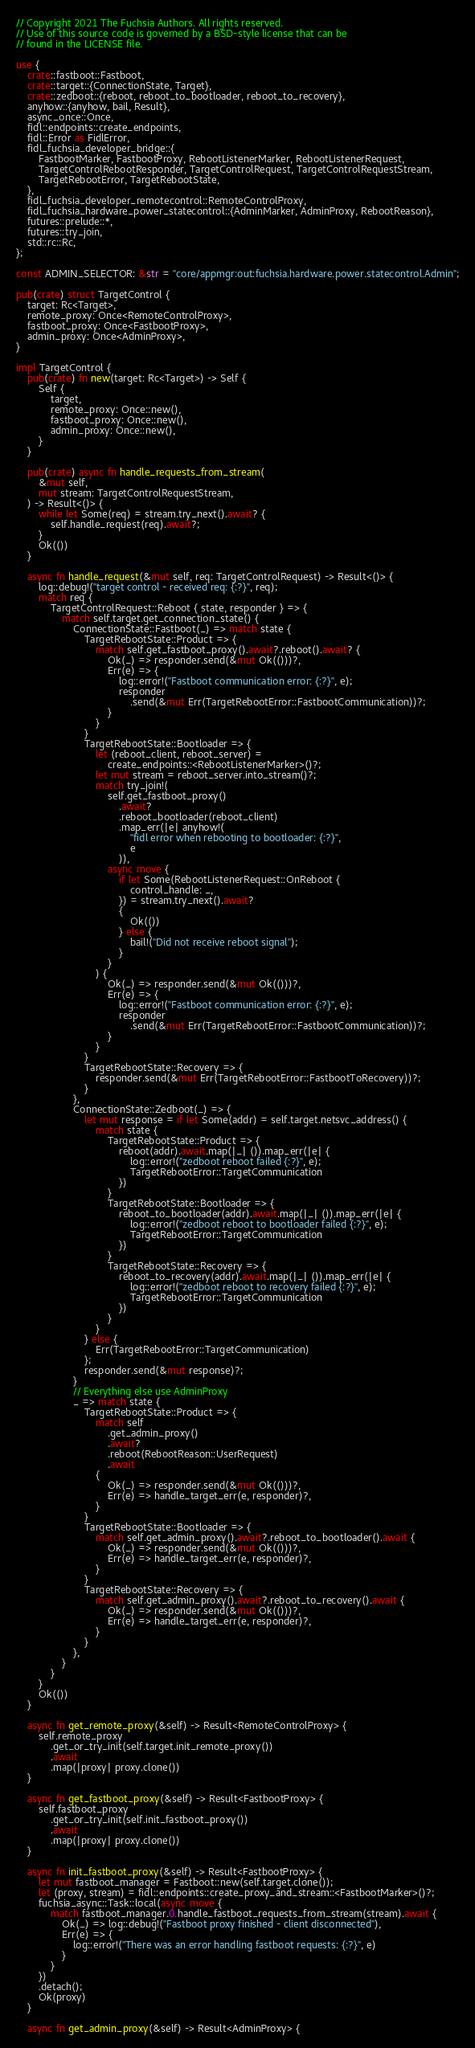Convert code to text. <code><loc_0><loc_0><loc_500><loc_500><_Rust_>// Copyright 2021 The Fuchsia Authors. All rights reserved.
// Use of this source code is governed by a BSD-style license that can be
// found in the LICENSE file.

use {
    crate::fastboot::Fastboot,
    crate::target::{ConnectionState, Target},
    crate::zedboot::{reboot, reboot_to_bootloader, reboot_to_recovery},
    anyhow::{anyhow, bail, Result},
    async_once::Once,
    fidl::endpoints::create_endpoints,
    fidl::Error as FidlError,
    fidl_fuchsia_developer_bridge::{
        FastbootMarker, FastbootProxy, RebootListenerMarker, RebootListenerRequest,
        TargetControlRebootResponder, TargetControlRequest, TargetControlRequestStream,
        TargetRebootError, TargetRebootState,
    },
    fidl_fuchsia_developer_remotecontrol::RemoteControlProxy,
    fidl_fuchsia_hardware_power_statecontrol::{AdminMarker, AdminProxy, RebootReason},
    futures::prelude::*,
    futures::try_join,
    std::rc::Rc,
};

const ADMIN_SELECTOR: &str = "core/appmgr:out:fuchsia.hardware.power.statecontrol.Admin";

pub(crate) struct TargetControl {
    target: Rc<Target>,
    remote_proxy: Once<RemoteControlProxy>,
    fastboot_proxy: Once<FastbootProxy>,
    admin_proxy: Once<AdminProxy>,
}

impl TargetControl {
    pub(crate) fn new(target: Rc<Target>) -> Self {
        Self {
            target,
            remote_proxy: Once::new(),
            fastboot_proxy: Once::new(),
            admin_proxy: Once::new(),
        }
    }

    pub(crate) async fn handle_requests_from_stream(
        &mut self,
        mut stream: TargetControlRequestStream,
    ) -> Result<()> {
        while let Some(req) = stream.try_next().await? {
            self.handle_request(req).await?;
        }
        Ok(())
    }

    async fn handle_request(&mut self, req: TargetControlRequest) -> Result<()> {
        log::debug!("target control - received req: {:?}", req);
        match req {
            TargetControlRequest::Reboot { state, responder } => {
                match self.target.get_connection_state() {
                    ConnectionState::Fastboot(_) => match state {
                        TargetRebootState::Product => {
                            match self.get_fastboot_proxy().await?.reboot().await? {
                                Ok(_) => responder.send(&mut Ok(()))?,
                                Err(e) => {
                                    log::error!("Fastboot communication error: {:?}", e);
                                    responder
                                        .send(&mut Err(TargetRebootError::FastbootCommunication))?;
                                }
                            }
                        }
                        TargetRebootState::Bootloader => {
                            let (reboot_client, reboot_server) =
                                create_endpoints::<RebootListenerMarker>()?;
                            let mut stream = reboot_server.into_stream()?;
                            match try_join!(
                                self.get_fastboot_proxy()
                                    .await?
                                    .reboot_bootloader(reboot_client)
                                    .map_err(|e| anyhow!(
                                        "fidl error when rebooting to bootloader: {:?}",
                                        e
                                    )),
                                async move {
                                    if let Some(RebootListenerRequest::OnReboot {
                                        control_handle: _,
                                    }) = stream.try_next().await?
                                    {
                                        Ok(())
                                    } else {
                                        bail!("Did not receive reboot signal");
                                    }
                                }
                            ) {
                                Ok(_) => responder.send(&mut Ok(()))?,
                                Err(e) => {
                                    log::error!("Fastboot communication error: {:?}", e);
                                    responder
                                        .send(&mut Err(TargetRebootError::FastbootCommunication))?;
                                }
                            }
                        }
                        TargetRebootState::Recovery => {
                            responder.send(&mut Err(TargetRebootError::FastbootToRecovery))?;
                        }
                    },
                    ConnectionState::Zedboot(_) => {
                        let mut response = if let Some(addr) = self.target.netsvc_address() {
                            match state {
                                TargetRebootState::Product => {
                                    reboot(addr).await.map(|_| ()).map_err(|e| {
                                        log::error!("zedboot reboot failed {:?}", e);
                                        TargetRebootError::TargetCommunication
                                    })
                                }
                                TargetRebootState::Bootloader => {
                                    reboot_to_bootloader(addr).await.map(|_| ()).map_err(|e| {
                                        log::error!("zedboot reboot to bootloader failed {:?}", e);
                                        TargetRebootError::TargetCommunication
                                    })
                                }
                                TargetRebootState::Recovery => {
                                    reboot_to_recovery(addr).await.map(|_| ()).map_err(|e| {
                                        log::error!("zedboot reboot to recovery failed {:?}", e);
                                        TargetRebootError::TargetCommunication
                                    })
                                }
                            }
                        } else {
                            Err(TargetRebootError::TargetCommunication)
                        };
                        responder.send(&mut response)?;
                    }
                    // Everything else use AdminProxy
                    _ => match state {
                        TargetRebootState::Product => {
                            match self
                                .get_admin_proxy()
                                .await?
                                .reboot(RebootReason::UserRequest)
                                .await
                            {
                                Ok(_) => responder.send(&mut Ok(()))?,
                                Err(e) => handle_target_err(e, responder)?,
                            }
                        }
                        TargetRebootState::Bootloader => {
                            match self.get_admin_proxy().await?.reboot_to_bootloader().await {
                                Ok(_) => responder.send(&mut Ok(()))?,
                                Err(e) => handle_target_err(e, responder)?,
                            }
                        }
                        TargetRebootState::Recovery => {
                            match self.get_admin_proxy().await?.reboot_to_recovery().await {
                                Ok(_) => responder.send(&mut Ok(()))?,
                                Err(e) => handle_target_err(e, responder)?,
                            }
                        }
                    },
                }
            }
        }
        Ok(())
    }

    async fn get_remote_proxy(&self) -> Result<RemoteControlProxy> {
        self.remote_proxy
            .get_or_try_init(self.target.init_remote_proxy())
            .await
            .map(|proxy| proxy.clone())
    }

    async fn get_fastboot_proxy(&self) -> Result<FastbootProxy> {
        self.fastboot_proxy
            .get_or_try_init(self.init_fastboot_proxy())
            .await
            .map(|proxy| proxy.clone())
    }

    async fn init_fastboot_proxy(&self) -> Result<FastbootProxy> {
        let mut fastboot_manager = Fastboot::new(self.target.clone());
        let (proxy, stream) = fidl::endpoints::create_proxy_and_stream::<FastbootMarker>()?;
        fuchsia_async::Task::local(async move {
            match fastboot_manager.0.handle_fastboot_requests_from_stream(stream).await {
                Ok(_) => log::debug!("Fastboot proxy finished - client disconnected"),
                Err(e) => {
                    log::error!("There was an error handling fastboot requests: {:?}", e)
                }
            }
        })
        .detach();
        Ok(proxy)
    }

    async fn get_admin_proxy(&self) -> Result<AdminProxy> {</code> 